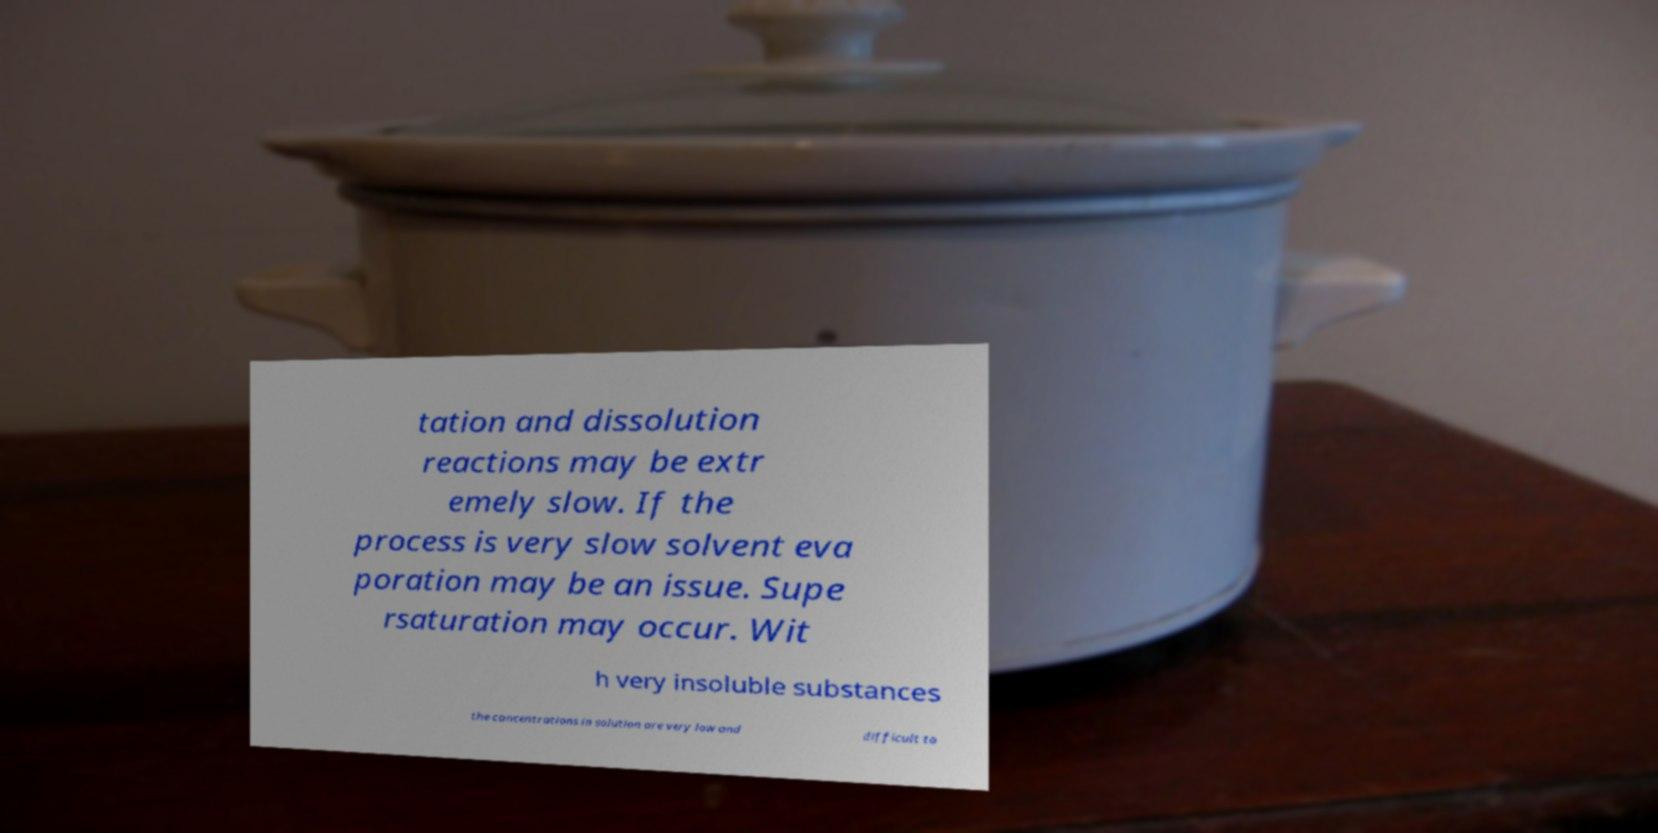For documentation purposes, I need the text within this image transcribed. Could you provide that? tation and dissolution reactions may be extr emely slow. If the process is very slow solvent eva poration may be an issue. Supe rsaturation may occur. Wit h very insoluble substances the concentrations in solution are very low and difficult to 